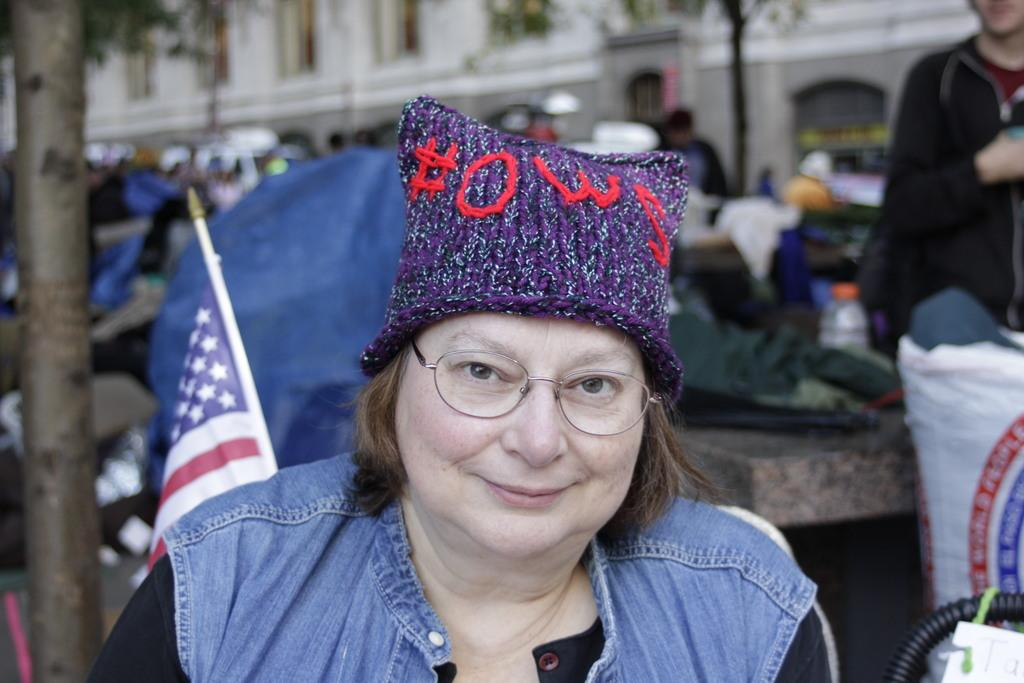Who is the main subject in the image? There is a lady in the image. What is the lady doing in the image? The lady is smiling. What can be seen beside the lady? There are objects beside the lady. Can you describe the people behind the lady? There are people behind the lady. What is visible in the background of the image? There are buildings and trees in the background of the image. What type of brake can be seen on the lady's bicycle in the image? There is no bicycle or brake present in the image. How many things does the lady's brother have in the image? There is no reference to a brother or any specific things in the image. 